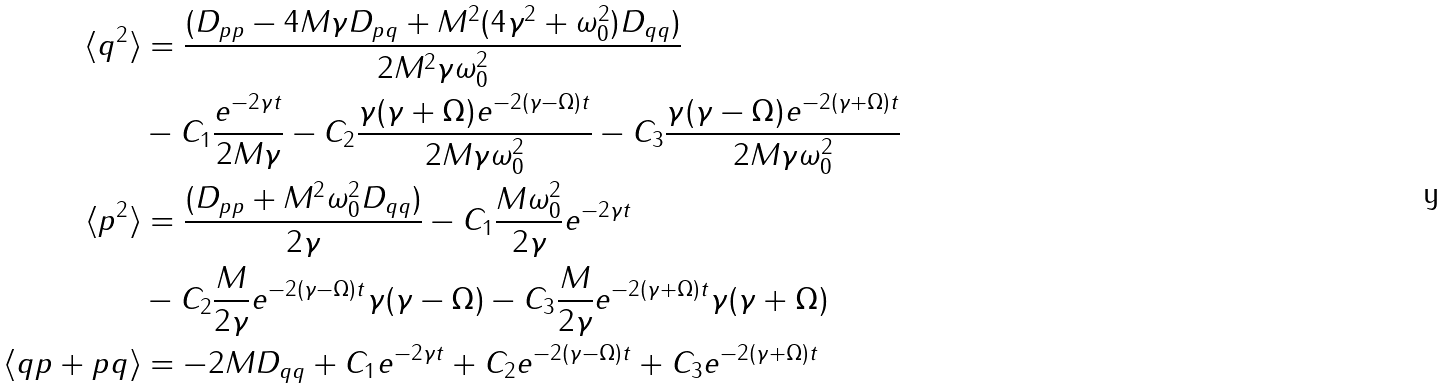<formula> <loc_0><loc_0><loc_500><loc_500>\langle q ^ { 2 } \rangle & = \frac { ( D _ { p p } - 4 M \gamma D _ { p q } + M ^ { 2 } ( 4 \gamma ^ { 2 } + \omega _ { 0 } ^ { 2 } ) D _ { q q } ) } { 2 M ^ { 2 } \gamma \omega _ { 0 } ^ { 2 } } \\ & - C _ { 1 } \frac { e ^ { - 2 \gamma t } } { 2 M \gamma } - C _ { 2 } \frac { \gamma ( \gamma + \Omega ) e ^ { - 2 ( \gamma - \Omega ) t } } { 2 M \gamma \omega _ { 0 } ^ { 2 } } - C _ { 3 } \frac { \gamma ( \gamma - \Omega ) e ^ { - 2 ( \gamma + \Omega ) t } } { 2 M \gamma \omega _ { 0 } ^ { 2 } } \\ \langle p ^ { 2 } \rangle & = \frac { ( D _ { p p } + M ^ { 2 } \omega _ { 0 } ^ { 2 } D _ { q q } ) } { 2 \gamma } - C _ { 1 } \frac { M \omega _ { 0 } ^ { 2 } } { 2 \gamma } e ^ { - 2 \gamma t } \\ & - C _ { 2 } \frac { M } { 2 \gamma } e ^ { - 2 ( \gamma - \Omega ) t } \gamma ( \gamma - \Omega ) - C _ { 3 } \frac { M } { 2 \gamma } e ^ { - 2 ( \gamma + \Omega ) t } \gamma ( \gamma + \Omega ) \\ \langle q p + p q \rangle & = - 2 M D _ { q q } + C _ { 1 } e ^ { - 2 \gamma t } + C _ { 2 } e ^ { - 2 ( \gamma - \Omega ) t } + C _ { 3 } e ^ { - 2 ( \gamma + \Omega ) t }</formula> 